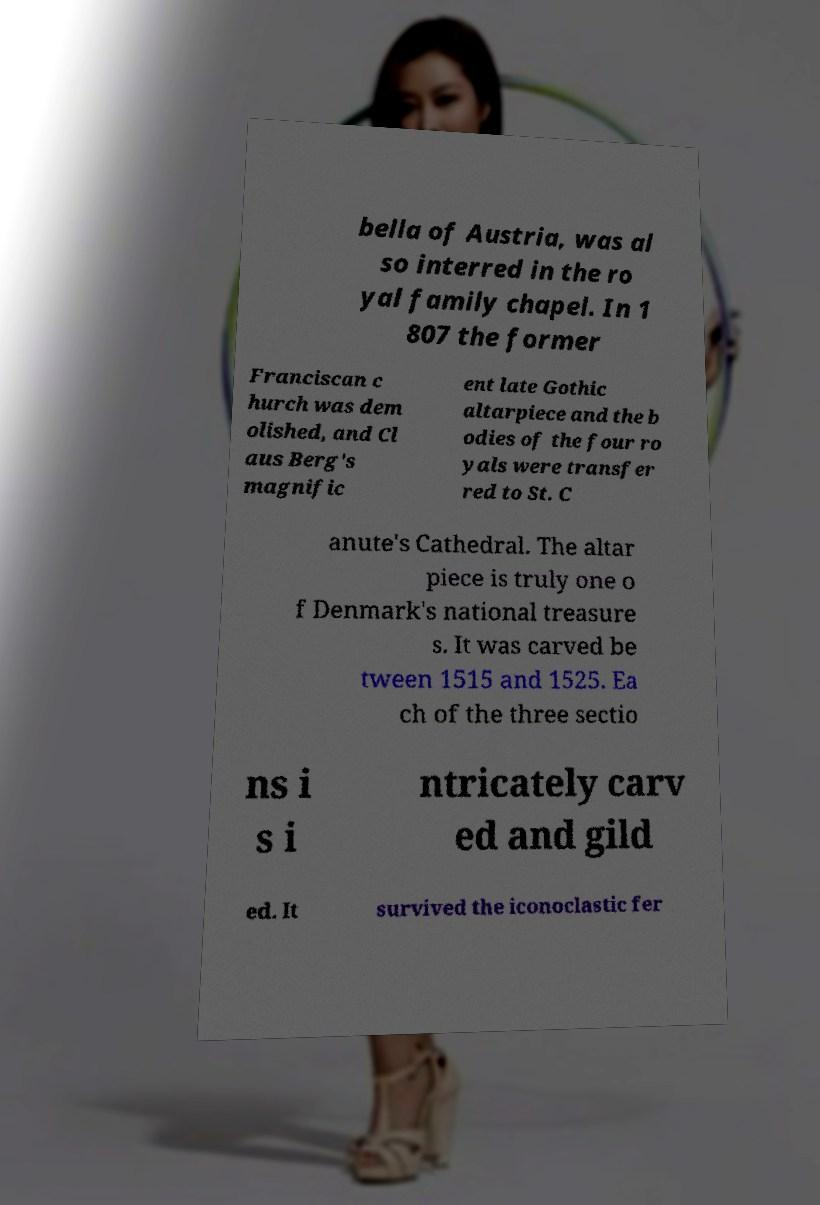Can you read and provide the text displayed in the image?This photo seems to have some interesting text. Can you extract and type it out for me? bella of Austria, was al so interred in the ro yal family chapel. In 1 807 the former Franciscan c hurch was dem olished, and Cl aus Berg's magnific ent late Gothic altarpiece and the b odies of the four ro yals were transfer red to St. C anute's Cathedral. The altar piece is truly one o f Denmark's national treasure s. It was carved be tween 1515 and 1525. Ea ch of the three sectio ns i s i ntricately carv ed and gild ed. It survived the iconoclastic fer 